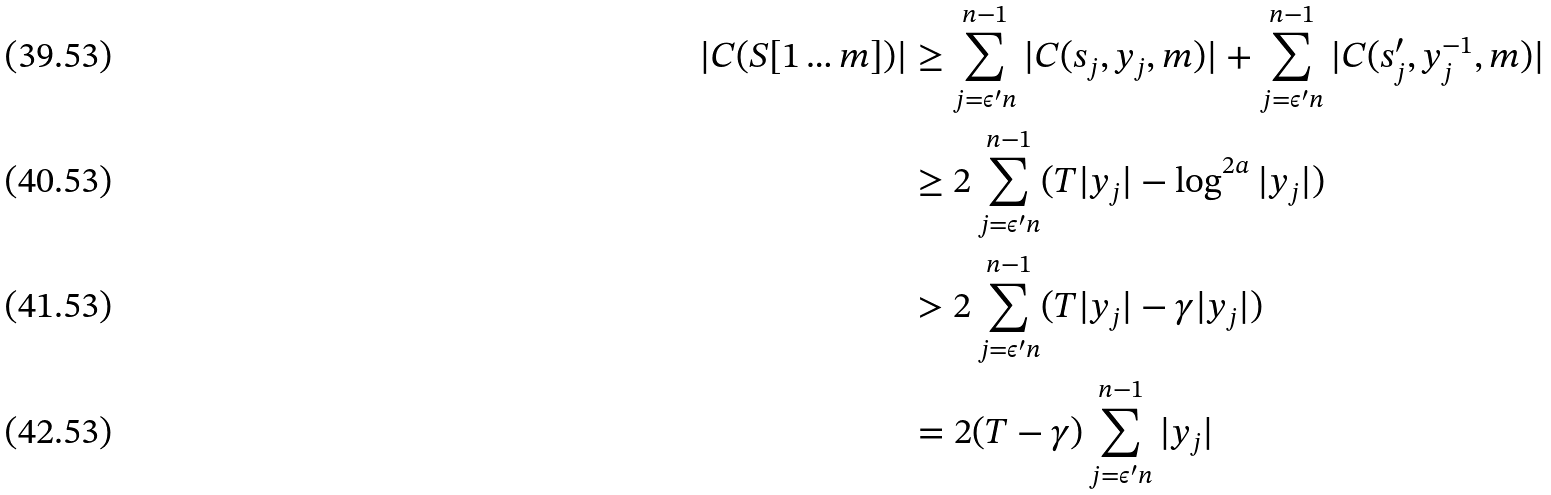<formula> <loc_0><loc_0><loc_500><loc_500>| C ( S [ 1 \dots m ] ) | & \geq \sum _ { j = \epsilon ^ { \prime } n } ^ { n - 1 } | C ( s _ { j } , y _ { j } , m ) | + \sum _ { j = \epsilon ^ { \prime } n } ^ { n - 1 } | C ( s ^ { \prime } _ { j } , y ^ { - 1 } _ { j } , m ) | \\ & \geq 2 \sum _ { j = \epsilon ^ { \prime } n } ^ { n - 1 } ( T | y _ { j } | - \log ^ { 2 a } | y _ { j } | ) \\ & > 2 \sum _ { j = \epsilon ^ { \prime } n } ^ { n - 1 } ( T | y _ { j } | - \gamma | y _ { j } | ) \\ & = 2 ( T - \gamma ) \sum _ { j = \epsilon ^ { \prime } n } ^ { n - 1 } | y _ { j } |</formula> 